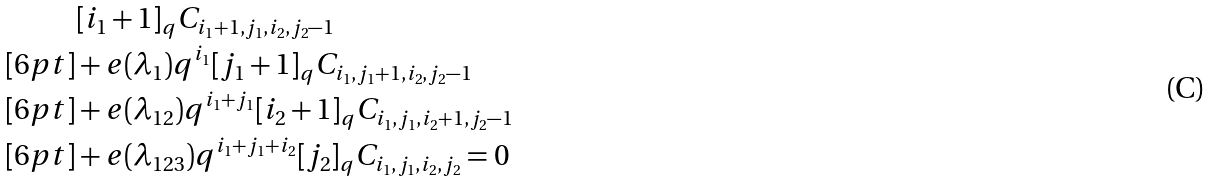<formula> <loc_0><loc_0><loc_500><loc_500>& [ i _ { 1 } + 1 ] _ { q } C _ { i _ { 1 } + 1 , j _ { 1 } , i _ { 2 } , j _ { 2 } - 1 } \\ [ 6 p t ] & + e ( \lambda _ { 1 } ) q ^ { i _ { 1 } } [ j _ { 1 } + 1 ] _ { q } C _ { i _ { 1 } , j _ { 1 } + 1 , i _ { 2 } , j _ { 2 } - 1 } \\ [ 6 p t ] & + e ( \lambda _ { 1 2 } ) q ^ { i _ { 1 } + j _ { 1 } } [ i _ { 2 } + 1 ] _ { q } C _ { i _ { 1 } , j _ { 1 } , i _ { 2 } + 1 , j _ { 2 } - 1 } \\ [ 6 p t ] & + e ( \lambda _ { 1 2 3 } ) q ^ { i _ { 1 } + j _ { 1 } + i _ { 2 } } [ j _ { 2 } ] _ { q } C _ { i _ { 1 } , j _ { 1 } , i _ { 2 } , j _ { 2 } } = 0</formula> 